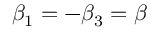Convert formula to latex. <formula><loc_0><loc_0><loc_500><loc_500>{ \beta _ { 1 } } = - { \beta _ { 3 } } = \beta</formula> 